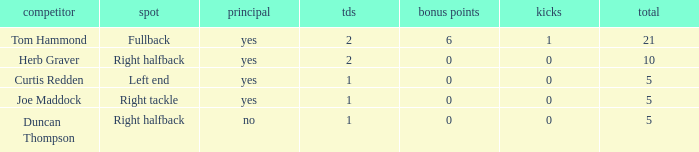Name the most extra points for right tackle 0.0. 